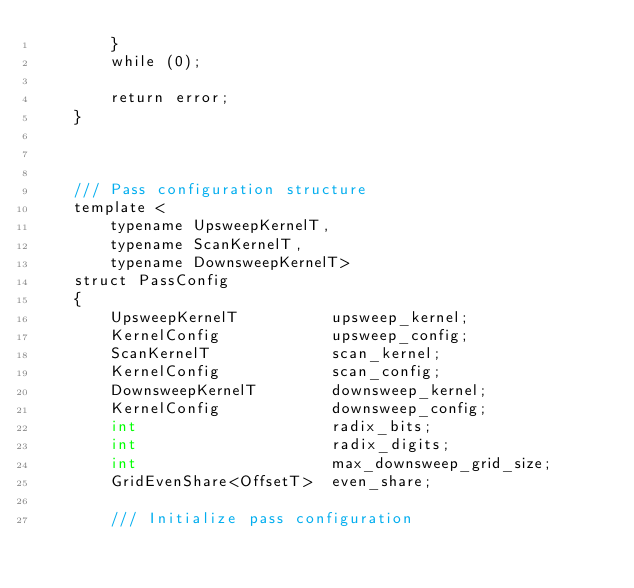Convert code to text. <code><loc_0><loc_0><loc_500><loc_500><_Cuda_>        }
        while (0);

        return error;
    }



    /// Pass configuration structure
    template <
        typename UpsweepKernelT,
        typename ScanKernelT,
        typename DownsweepKernelT>
    struct PassConfig
    {
        UpsweepKernelT          upsweep_kernel;
        KernelConfig            upsweep_config;
        ScanKernelT             scan_kernel;
        KernelConfig            scan_config;
        DownsweepKernelT        downsweep_kernel;
        KernelConfig            downsweep_config;
        int                     radix_bits;
        int                     radix_digits;
        int                     max_downsweep_grid_size;
        GridEvenShare<OffsetT>  even_share;

        /// Initialize pass configuration</code> 